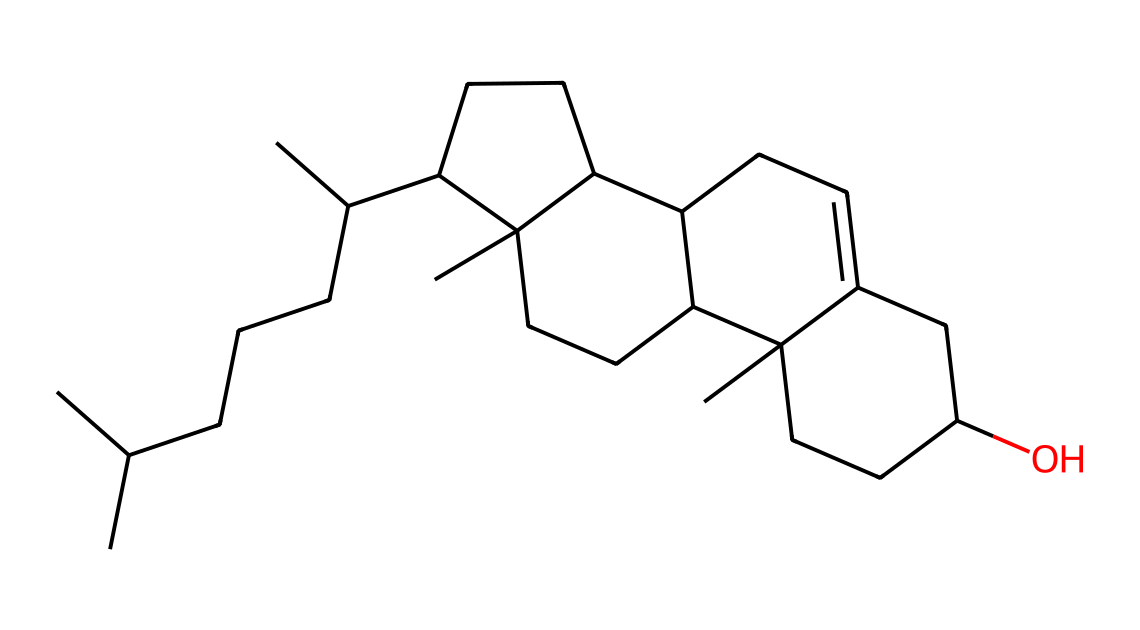What is the name of this chemical? The provided SMILES represents the molecular structure of cholesterol, a sterol, which is a type of lipid.
Answer: cholesterol How many carbon atoms are in this molecule? By counting the carbon atoms from the SMILES structure, we find there are 27 carbon atoms in cholesterol.
Answer: 27 Does this chemical contain any hydroxyl groups? The presence of "O" in the SMILES indicates that there is at least one hydroxyl (alcohol) group in the molecule, specifically on one of the carbon atoms.
Answer: yes What is the primary role of cholesterol in cell membranes? Cholesterol contributes to membrane fluidity and stability, helping to maintain the integrity of cell membranes at various temperatures.
Answer: fluidity How many rings are present in the cholesterol structure? Analyzing the chemical structure, cholesterol has four fused rings, which is characteristic of sterols.
Answer: four What type of lipid is cholesterol classified as? Cholesterol is classified as a sterol, which is a subclass of steroids.
Answer: sterol What effect does cholesterol have on membrane permeability? Cholesterol reduces membrane permeability, making membranes less permeable to small water-soluble molecules.
Answer: decreases 